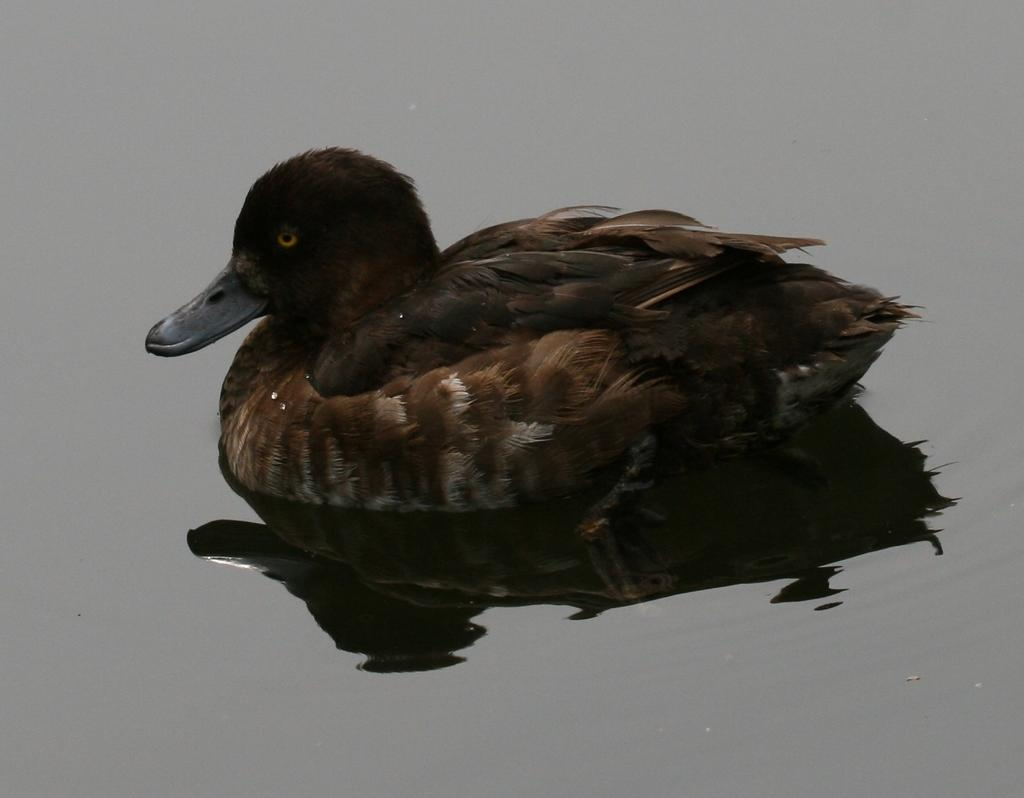What type of animal is in the image? There is a black duck in the image. Where is the duck located? The duck is on the water. What type of stew is the mother making with celery in the image? There is no mother or stew present in the image; it only features a black duck on the water. 